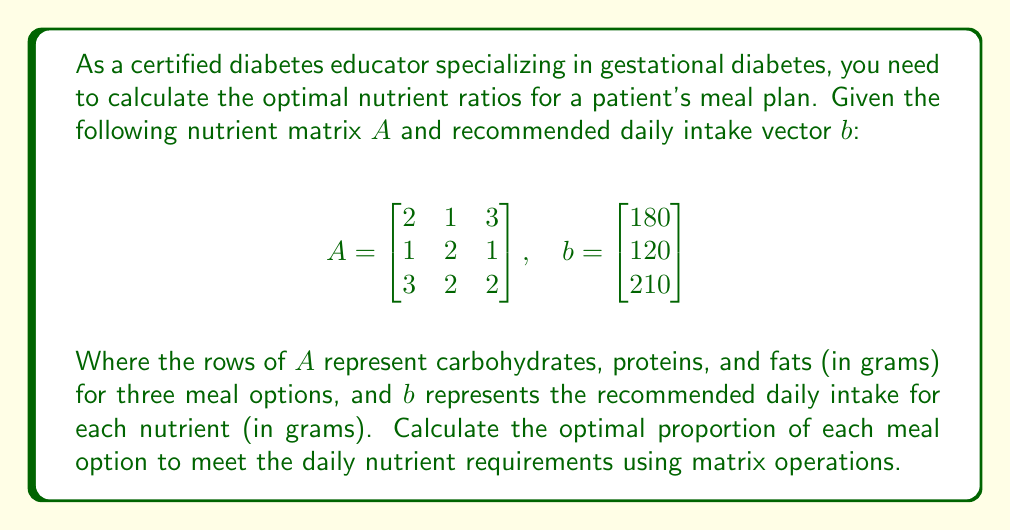What is the answer to this math problem? To solve this problem, we need to find a vector $x$ that satisfies the equation $Ax = b$. This vector $x$ will represent the optimal proportions of each meal option.

Step 1: Set up the equation $Ax = b$
$$\begin{bmatrix}
2 & 1 & 3 \\
1 & 2 & 1 \\
3 & 2 & 2
\end{bmatrix} \begin{bmatrix}
x_1 \\
x_2 \\
x_3
\end{bmatrix} = \begin{bmatrix}
180 \\
120 \\
210
\end{bmatrix}$$

Step 2: Calculate the inverse of matrix $A$
$$A^{-1} = \frac{1}{9} \begin{bmatrix}
2 & -3 & 1 \\
-1 & 3 & -1 \\
1 & -1 & 1
\end{bmatrix}$$

Step 3: Multiply both sides of the equation by $A^{-1}$
$$A^{-1}Ax = A^{-1}b$$
$$Ix = A^{-1}b$$
$$x = A^{-1}b$$

Step 4: Perform the matrix multiplication
$$x = \frac{1}{9} \begin{bmatrix}
2 & -3 & 1 \\
-1 & 3 & -1 \\
1 & -1 & 1
\end{bmatrix} \begin{bmatrix}
180 \\
120 \\
210
\end{bmatrix}$$

$$x = \frac{1}{9} \begin{bmatrix}
2(180) + (-3)(120) + 1(210) \\
(-1)(180) + 3(120) + (-1)(210) \\
1(180) + (-1)(120) + 1(210)
\end{bmatrix}$$

$$x = \frac{1}{9} \begin{bmatrix}
360 - 360 + 210 \\
-180 + 360 - 210 \\
180 - 120 + 210
\end{bmatrix} = \begin{bmatrix}
210/9 \\
-30/9 \\
270/9
\end{bmatrix}$$

Step 5: Simplify the result
$$x = \begin{bmatrix}
70/3 \\
-10/3 \\
90/3
\end{bmatrix} = \begin{bmatrix}
23.33 \\
-3.33 \\
30
\end{bmatrix}$$

The negative value for $x_2$ is not practical for meal planning. To address this, we can set $x_2 = 0$ and recalculate the proportions for $x_1$ and $x_3$ using a reduced system:

$$\begin{bmatrix}
2 & 3 \\
1 & 1 \\
3 & 2
\end{bmatrix} \begin{bmatrix}
x_1 \\
x_3
\end{bmatrix} = \begin{bmatrix}
180 \\
120 \\
210
\end{bmatrix}$$

Solving this system using the same method as before, we get:

$$\begin{bmatrix}
x_1 \\
x_3
\end{bmatrix} = \begin{bmatrix}
30 \\
40
\end{bmatrix}$$

Therefore, the optimal proportions for the meal plan are 30 units of meal option 1 and 40 units of meal option 3.
Answer: The optimal proportions for the meal plan are:
Meal option 1: 30 units
Meal option 2: 0 units
Meal option 3: 40 units 